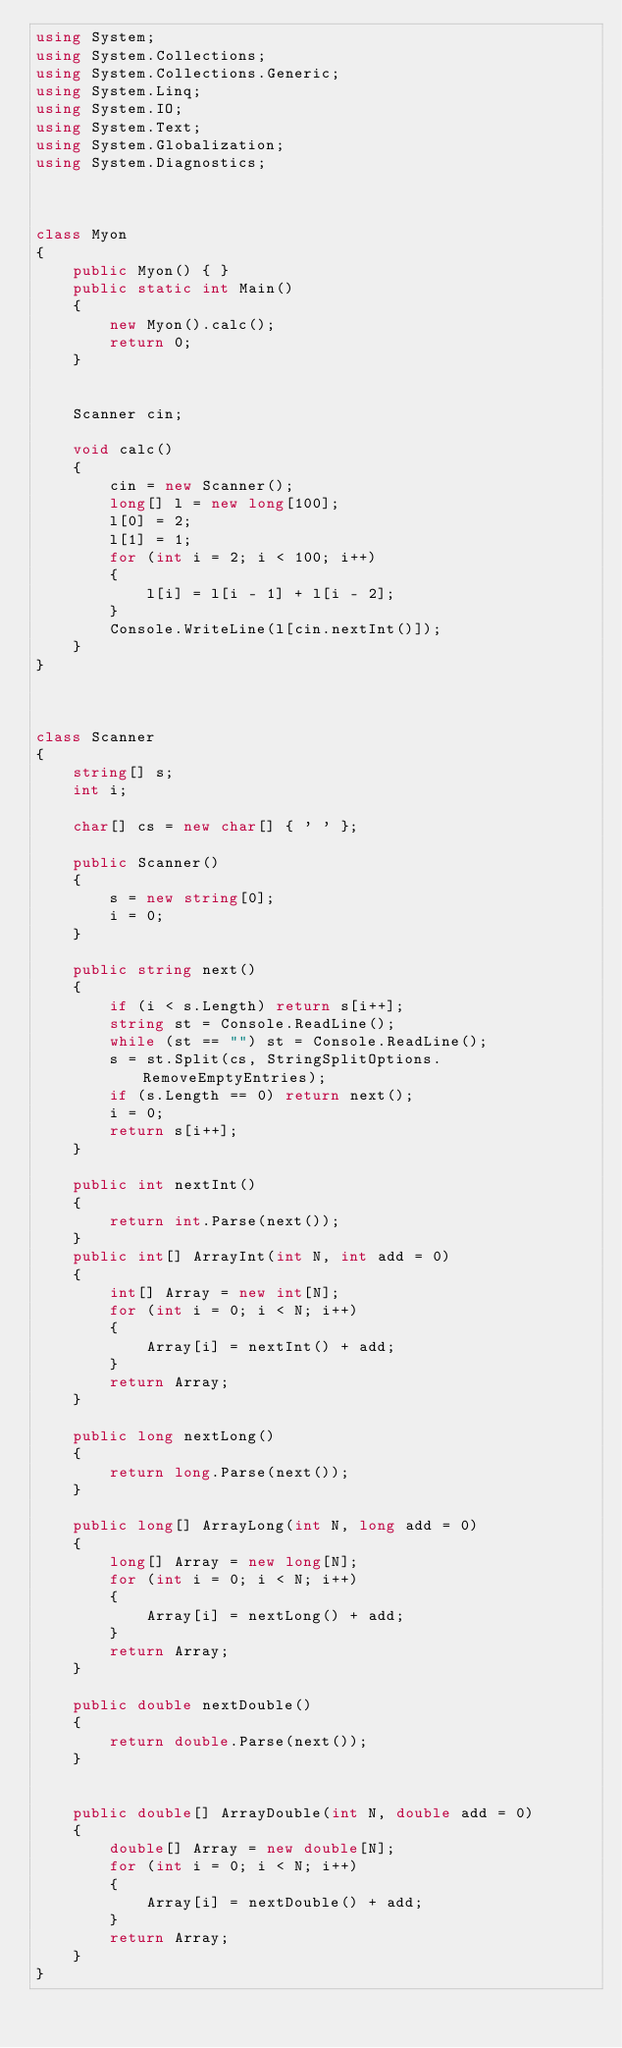<code> <loc_0><loc_0><loc_500><loc_500><_C#_>using System;
using System.Collections;
using System.Collections.Generic;
using System.Linq;
using System.IO;
using System.Text;
using System.Globalization;
using System.Diagnostics;



class Myon
{
    public Myon() { }
    public static int Main()
    {
        new Myon().calc();
        return 0;
    }
    

    Scanner cin;
    
    void calc()
    {
        cin = new Scanner();
        long[] l = new long[100];
        l[0] = 2;
        l[1] = 1;
        for (int i = 2; i < 100; i++)
        {
            l[i] = l[i - 1] + l[i - 2];
        }
        Console.WriteLine(l[cin.nextInt()]);
    }
}



class Scanner
{
    string[] s;
    int i;

    char[] cs = new char[] { ' ' };

    public Scanner()
    {
        s = new string[0];
        i = 0;
    }

    public string next()
    {
        if (i < s.Length) return s[i++];
        string st = Console.ReadLine();
        while (st == "") st = Console.ReadLine();
        s = st.Split(cs, StringSplitOptions.RemoveEmptyEntries);
        if (s.Length == 0) return next();
        i = 0;
        return s[i++];
    }

    public int nextInt()
    {
        return int.Parse(next());
    }
    public int[] ArrayInt(int N, int add = 0)
    {
        int[] Array = new int[N];
        for (int i = 0; i < N; i++)
        {
            Array[i] = nextInt() + add;
        }
        return Array;
    }

    public long nextLong()
    {
        return long.Parse(next());
    }

    public long[] ArrayLong(int N, long add = 0)
    {
        long[] Array = new long[N];
        for (int i = 0; i < N; i++)
        {
            Array[i] = nextLong() + add;
        }
        return Array;
    }

    public double nextDouble()
    {
        return double.Parse(next());
    }


    public double[] ArrayDouble(int N, double add = 0)
    {
        double[] Array = new double[N];
        for (int i = 0; i < N; i++)
        {
            Array[i] = nextDouble() + add;
        }
        return Array;
    }
}</code> 